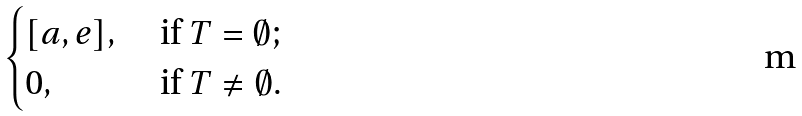<formula> <loc_0><loc_0><loc_500><loc_500>\begin{cases} [ a , e ] , \ & \text {if} \ T = \emptyset ; \\ 0 , \ & \text {if} \ T \neq \emptyset . \end{cases}</formula> 